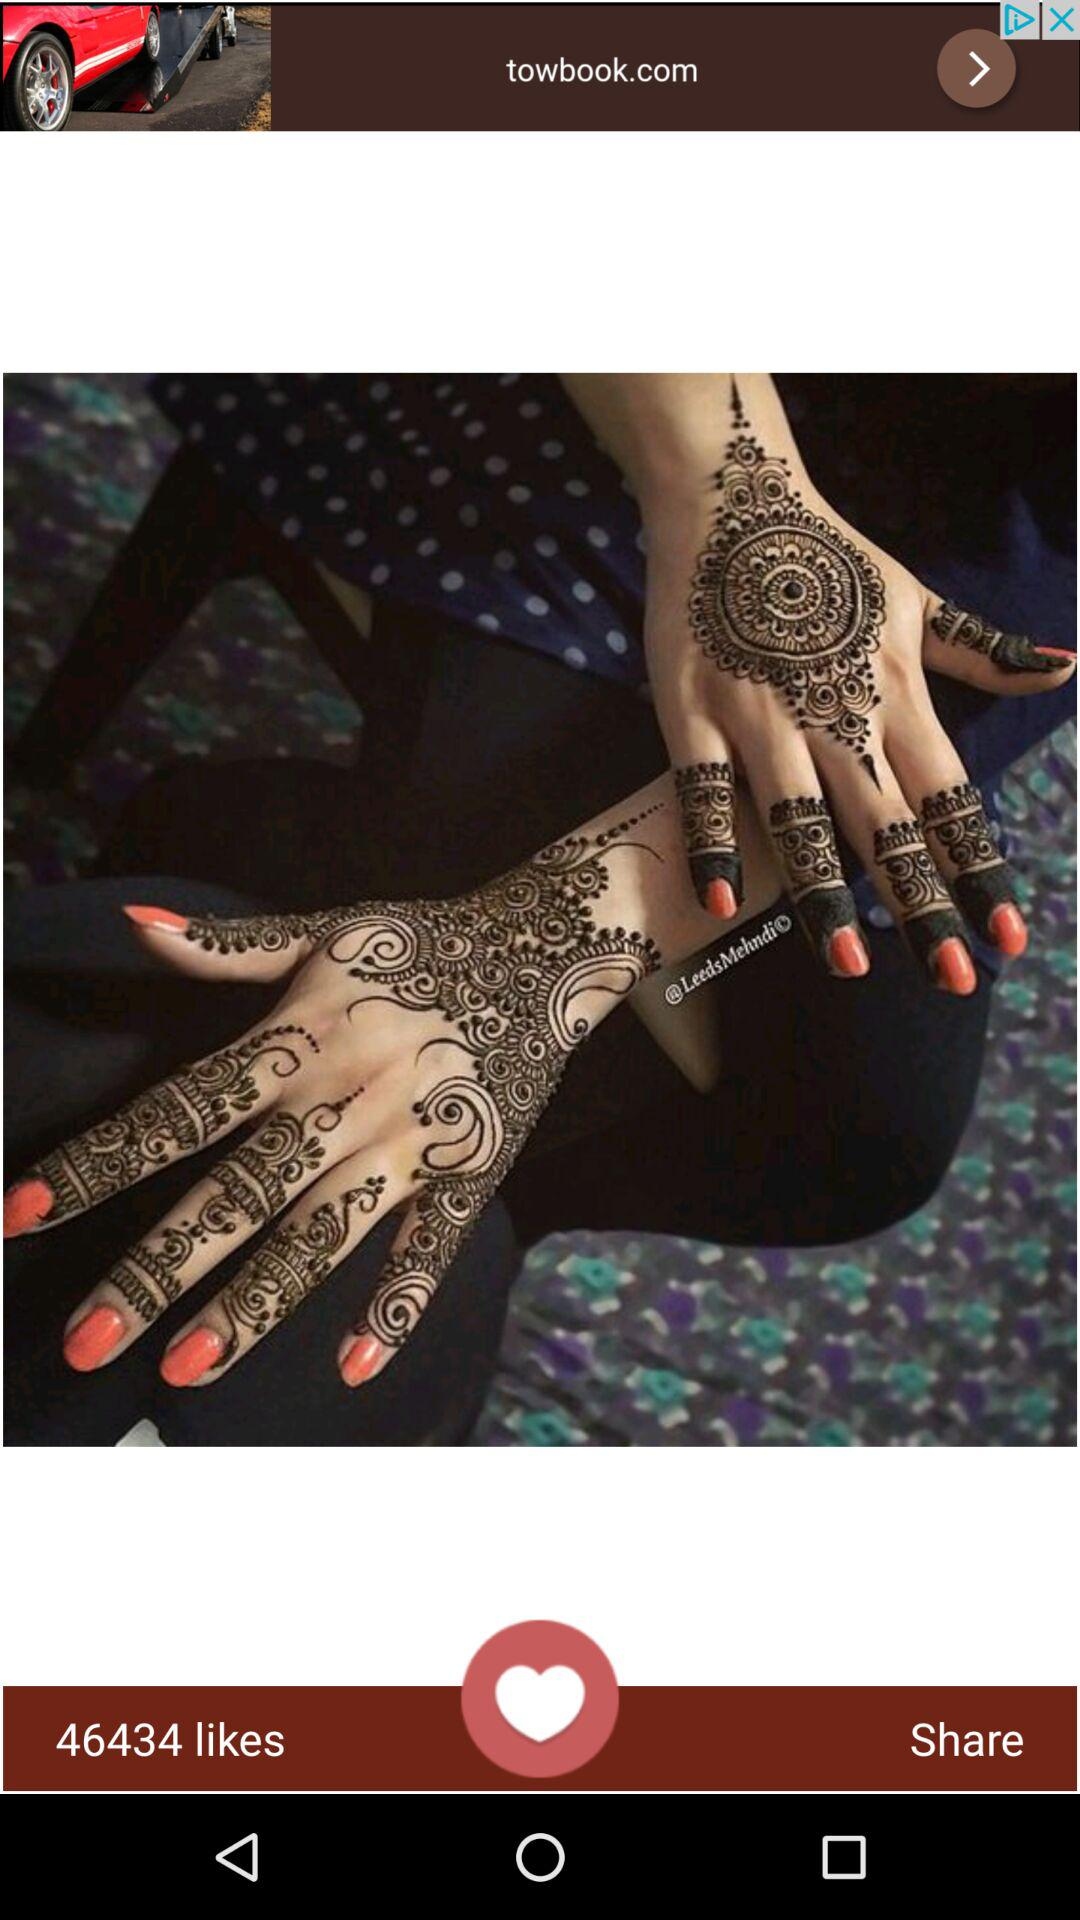How many likes are there? There are 46434 likes. 